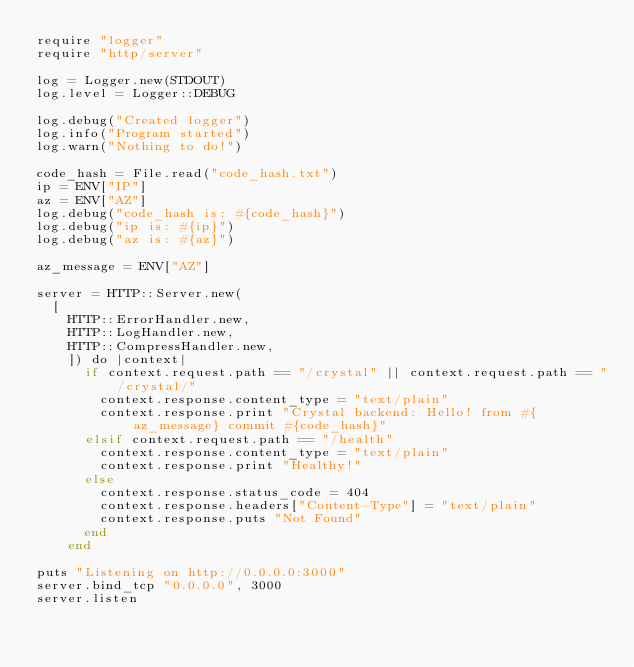Convert code to text. <code><loc_0><loc_0><loc_500><loc_500><_Crystal_>require "logger"
require "http/server"

log = Logger.new(STDOUT)
log.level = Logger::DEBUG

log.debug("Created logger")
log.info("Program started")
log.warn("Nothing to do!")

code_hash = File.read("code_hash.txt")
ip = ENV["IP"]
az = ENV["AZ"]
log.debug("code_hash is: #{code_hash}")
log.debug("ip is: #{ip}")
log.debug("az is: #{az}")

az_message = ENV["AZ"]

server = HTTP::Server.new(
  [
    HTTP::ErrorHandler.new,
    HTTP::LogHandler.new,
    HTTP::CompressHandler.new,
    ]) do |context|
      if context.request.path == "/crystal" || context.request.path == "/crystal/"
        context.response.content_type = "text/plain"
        context.response.print "Crystal backend: Hello! from #{az_message} commit #{code_hash}"
      elsif context.request.path == "/health"
        context.response.content_type = "text/plain"
        context.response.print "Healthy!"
      else
        context.response.status_code = 404
        context.response.headers["Content-Type"] = "text/plain"
        context.response.puts "Not Found"
      end
    end

puts "Listening on http://0.0.0.0:3000"
server.bind_tcp "0.0.0.0", 3000
server.listen
</code> 